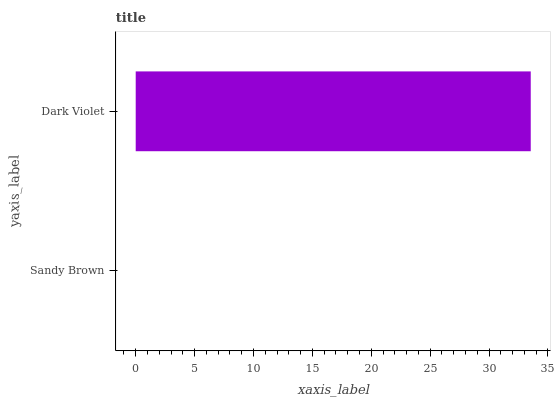Is Sandy Brown the minimum?
Answer yes or no. Yes. Is Dark Violet the maximum?
Answer yes or no. Yes. Is Dark Violet the minimum?
Answer yes or no. No. Is Dark Violet greater than Sandy Brown?
Answer yes or no. Yes. Is Sandy Brown less than Dark Violet?
Answer yes or no. Yes. Is Sandy Brown greater than Dark Violet?
Answer yes or no. No. Is Dark Violet less than Sandy Brown?
Answer yes or no. No. Is Dark Violet the high median?
Answer yes or no. Yes. Is Sandy Brown the low median?
Answer yes or no. Yes. Is Sandy Brown the high median?
Answer yes or no. No. Is Dark Violet the low median?
Answer yes or no. No. 